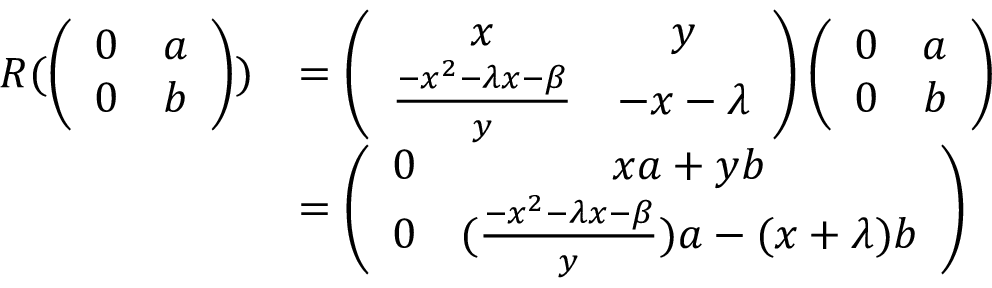<formula> <loc_0><loc_0><loc_500><loc_500>\begin{array} { r l } { R ( \left ( \begin{array} { c c } { 0 } & { a } \\ { 0 } & { b } \end{array} \right ) ) } & { = \left ( \begin{array} { c c } { x } & { y } \\ { \frac { - x ^ { 2 } - \lambda x - \beta } { y } } & { - x - \lambda } \end{array} \right ) \left ( \begin{array} { c c } { 0 } & { a } \\ { 0 } & { b } \end{array} \right ) } \\ & { = \left ( \begin{array} { c c } { 0 } & { x a + y b } \\ { 0 } & { ( \frac { - x ^ { 2 } - \lambda x - \beta } { y } ) a - ( x + \lambda ) b } \end{array} \right ) } \end{array}</formula> 